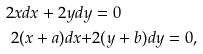Convert formula to latex. <formula><loc_0><loc_0><loc_500><loc_500>2 x d x + 2 y d y & = 0 \quad \\ 2 ( x + a ) d x + & 2 ( y + b ) d y = 0 ,</formula> 